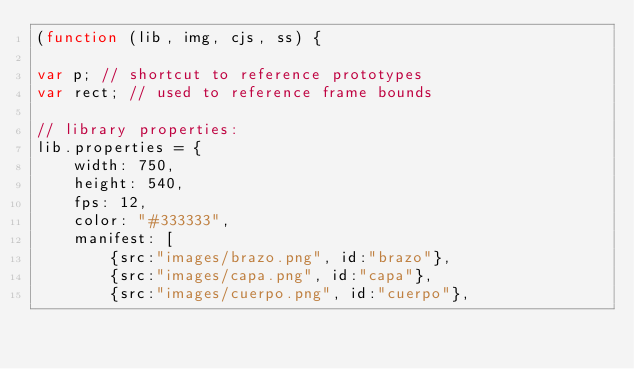<code> <loc_0><loc_0><loc_500><loc_500><_JavaScript_>(function (lib, img, cjs, ss) {

var p; // shortcut to reference prototypes
var rect; // used to reference frame bounds

// library properties:
lib.properties = {
	width: 750,
	height: 540,
	fps: 12,
	color: "#333333",
	manifest: [
		{src:"images/brazo.png", id:"brazo"},
		{src:"images/capa.png", id:"capa"},
		{src:"images/cuerpo.png", id:"cuerpo"},</code> 